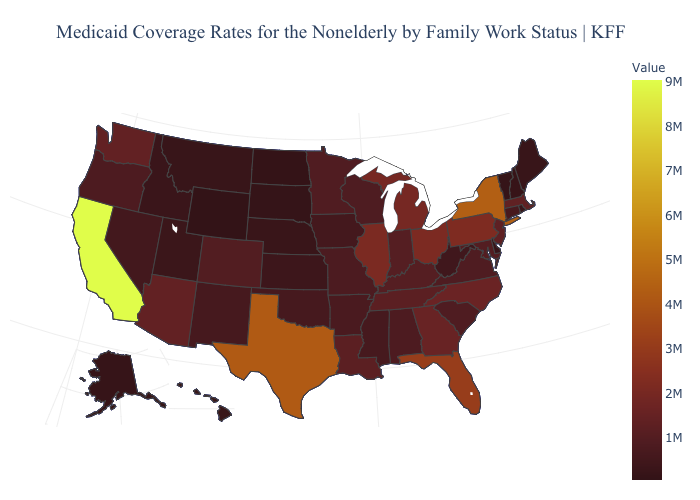Among the states that border Idaho , which have the highest value?
Quick response, please. Washington. Which states have the lowest value in the USA?
Be succinct. Wyoming. Among the states that border New York , does Vermont have the highest value?
Keep it brief. No. Does Kentucky have a higher value than Illinois?
Keep it brief. No. 